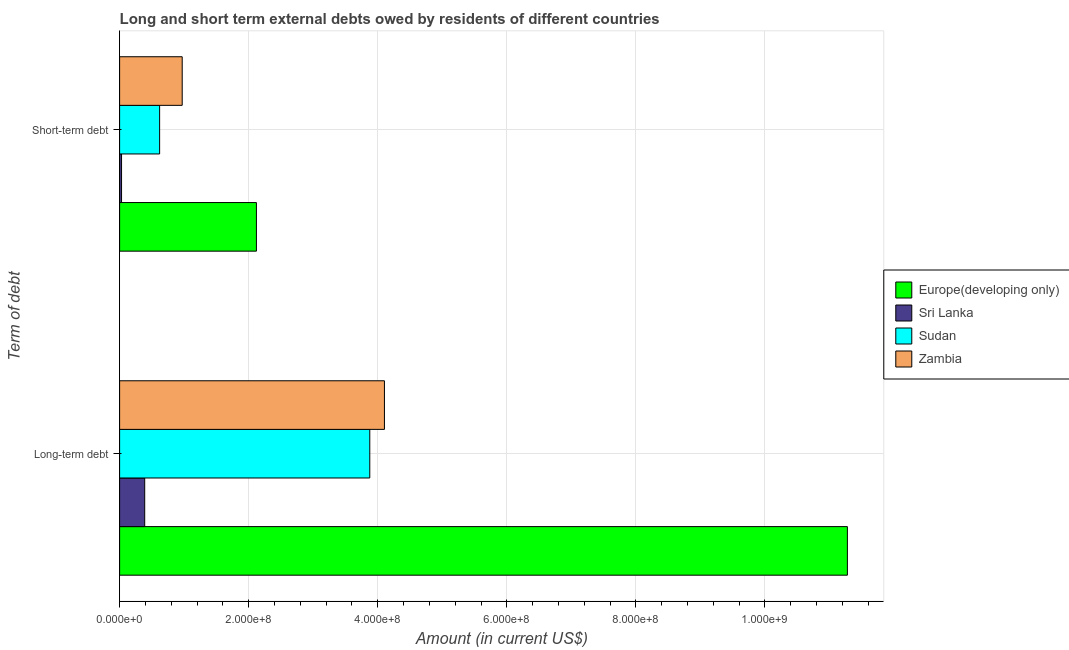Are the number of bars per tick equal to the number of legend labels?
Offer a terse response. Yes. How many bars are there on the 2nd tick from the top?
Make the answer very short. 4. What is the label of the 2nd group of bars from the top?
Provide a succinct answer. Long-term debt. What is the short-term debts owed by residents in Sudan?
Provide a succinct answer. 6.20e+07. Across all countries, what is the maximum long-term debts owed by residents?
Give a very brief answer. 1.13e+09. Across all countries, what is the minimum short-term debts owed by residents?
Provide a short and direct response. 3.00e+06. In which country was the long-term debts owed by residents maximum?
Make the answer very short. Europe(developing only). In which country was the long-term debts owed by residents minimum?
Provide a short and direct response. Sri Lanka. What is the total short-term debts owed by residents in the graph?
Ensure brevity in your answer.  3.74e+08. What is the difference between the long-term debts owed by residents in Europe(developing only) and that in Zambia?
Give a very brief answer. 7.17e+08. What is the difference between the short-term debts owed by residents in Europe(developing only) and the long-term debts owed by residents in Sudan?
Keep it short and to the point. -1.76e+08. What is the average short-term debts owed by residents per country?
Your response must be concise. 9.35e+07. What is the difference between the short-term debts owed by residents and long-term debts owed by residents in Zambia?
Keep it short and to the point. -3.13e+08. In how many countries, is the short-term debts owed by residents greater than 1040000000 US$?
Make the answer very short. 0. What is the ratio of the short-term debts owed by residents in Sudan to that in Europe(developing only)?
Provide a succinct answer. 0.29. Is the short-term debts owed by residents in Sri Lanka less than that in Zambia?
Your answer should be very brief. Yes. What does the 4th bar from the top in Long-term debt represents?
Provide a succinct answer. Europe(developing only). What does the 4th bar from the bottom in Short-term debt represents?
Your answer should be very brief. Zambia. Are all the bars in the graph horizontal?
Keep it short and to the point. Yes. How many countries are there in the graph?
Provide a short and direct response. 4. Does the graph contain any zero values?
Your response must be concise. No. What is the title of the graph?
Your answer should be very brief. Long and short term external debts owed by residents of different countries. What is the label or title of the X-axis?
Provide a succinct answer. Amount (in current US$). What is the label or title of the Y-axis?
Give a very brief answer. Term of debt. What is the Amount (in current US$) of Europe(developing only) in Long-term debt?
Offer a terse response. 1.13e+09. What is the Amount (in current US$) of Sri Lanka in Long-term debt?
Ensure brevity in your answer.  3.89e+07. What is the Amount (in current US$) in Sudan in Long-term debt?
Give a very brief answer. 3.88e+08. What is the Amount (in current US$) in Zambia in Long-term debt?
Keep it short and to the point. 4.10e+08. What is the Amount (in current US$) in Europe(developing only) in Short-term debt?
Offer a terse response. 2.12e+08. What is the Amount (in current US$) of Sri Lanka in Short-term debt?
Offer a terse response. 3.00e+06. What is the Amount (in current US$) in Sudan in Short-term debt?
Your response must be concise. 6.20e+07. What is the Amount (in current US$) of Zambia in Short-term debt?
Ensure brevity in your answer.  9.70e+07. Across all Term of debt, what is the maximum Amount (in current US$) of Europe(developing only)?
Your response must be concise. 1.13e+09. Across all Term of debt, what is the maximum Amount (in current US$) in Sri Lanka?
Ensure brevity in your answer.  3.89e+07. Across all Term of debt, what is the maximum Amount (in current US$) of Sudan?
Your answer should be very brief. 3.88e+08. Across all Term of debt, what is the maximum Amount (in current US$) in Zambia?
Provide a short and direct response. 4.10e+08. Across all Term of debt, what is the minimum Amount (in current US$) of Europe(developing only)?
Keep it short and to the point. 2.12e+08. Across all Term of debt, what is the minimum Amount (in current US$) of Sri Lanka?
Ensure brevity in your answer.  3.00e+06. Across all Term of debt, what is the minimum Amount (in current US$) of Sudan?
Offer a very short reply. 6.20e+07. Across all Term of debt, what is the minimum Amount (in current US$) of Zambia?
Offer a very short reply. 9.70e+07. What is the total Amount (in current US$) in Europe(developing only) in the graph?
Provide a short and direct response. 1.34e+09. What is the total Amount (in current US$) in Sri Lanka in the graph?
Give a very brief answer. 4.19e+07. What is the total Amount (in current US$) of Sudan in the graph?
Your answer should be very brief. 4.50e+08. What is the total Amount (in current US$) of Zambia in the graph?
Provide a succinct answer. 5.07e+08. What is the difference between the Amount (in current US$) in Europe(developing only) in Long-term debt and that in Short-term debt?
Offer a very short reply. 9.16e+08. What is the difference between the Amount (in current US$) in Sri Lanka in Long-term debt and that in Short-term debt?
Ensure brevity in your answer.  3.59e+07. What is the difference between the Amount (in current US$) in Sudan in Long-term debt and that in Short-term debt?
Offer a very short reply. 3.26e+08. What is the difference between the Amount (in current US$) in Zambia in Long-term debt and that in Short-term debt?
Your answer should be very brief. 3.13e+08. What is the difference between the Amount (in current US$) of Europe(developing only) in Long-term debt and the Amount (in current US$) of Sri Lanka in Short-term debt?
Keep it short and to the point. 1.12e+09. What is the difference between the Amount (in current US$) in Europe(developing only) in Long-term debt and the Amount (in current US$) in Sudan in Short-term debt?
Give a very brief answer. 1.07e+09. What is the difference between the Amount (in current US$) of Europe(developing only) in Long-term debt and the Amount (in current US$) of Zambia in Short-term debt?
Ensure brevity in your answer.  1.03e+09. What is the difference between the Amount (in current US$) of Sri Lanka in Long-term debt and the Amount (in current US$) of Sudan in Short-term debt?
Offer a very short reply. -2.31e+07. What is the difference between the Amount (in current US$) in Sri Lanka in Long-term debt and the Amount (in current US$) in Zambia in Short-term debt?
Provide a short and direct response. -5.81e+07. What is the difference between the Amount (in current US$) of Sudan in Long-term debt and the Amount (in current US$) of Zambia in Short-term debt?
Your answer should be very brief. 2.91e+08. What is the average Amount (in current US$) of Europe(developing only) per Term of debt?
Ensure brevity in your answer.  6.70e+08. What is the average Amount (in current US$) of Sri Lanka per Term of debt?
Ensure brevity in your answer.  2.09e+07. What is the average Amount (in current US$) of Sudan per Term of debt?
Offer a terse response. 2.25e+08. What is the average Amount (in current US$) in Zambia per Term of debt?
Give a very brief answer. 2.54e+08. What is the difference between the Amount (in current US$) of Europe(developing only) and Amount (in current US$) of Sri Lanka in Long-term debt?
Make the answer very short. 1.09e+09. What is the difference between the Amount (in current US$) of Europe(developing only) and Amount (in current US$) of Sudan in Long-term debt?
Ensure brevity in your answer.  7.40e+08. What is the difference between the Amount (in current US$) of Europe(developing only) and Amount (in current US$) of Zambia in Long-term debt?
Your answer should be compact. 7.17e+08. What is the difference between the Amount (in current US$) of Sri Lanka and Amount (in current US$) of Sudan in Long-term debt?
Keep it short and to the point. -3.49e+08. What is the difference between the Amount (in current US$) in Sri Lanka and Amount (in current US$) in Zambia in Long-term debt?
Your answer should be compact. -3.71e+08. What is the difference between the Amount (in current US$) in Sudan and Amount (in current US$) in Zambia in Long-term debt?
Offer a very short reply. -2.27e+07. What is the difference between the Amount (in current US$) in Europe(developing only) and Amount (in current US$) in Sri Lanka in Short-term debt?
Your answer should be compact. 2.09e+08. What is the difference between the Amount (in current US$) of Europe(developing only) and Amount (in current US$) of Sudan in Short-term debt?
Your answer should be compact. 1.50e+08. What is the difference between the Amount (in current US$) of Europe(developing only) and Amount (in current US$) of Zambia in Short-term debt?
Your response must be concise. 1.15e+08. What is the difference between the Amount (in current US$) of Sri Lanka and Amount (in current US$) of Sudan in Short-term debt?
Your answer should be compact. -5.90e+07. What is the difference between the Amount (in current US$) in Sri Lanka and Amount (in current US$) in Zambia in Short-term debt?
Your answer should be compact. -9.40e+07. What is the difference between the Amount (in current US$) of Sudan and Amount (in current US$) of Zambia in Short-term debt?
Offer a terse response. -3.50e+07. What is the ratio of the Amount (in current US$) of Europe(developing only) in Long-term debt to that in Short-term debt?
Your answer should be very brief. 5.32. What is the ratio of the Amount (in current US$) in Sri Lanka in Long-term debt to that in Short-term debt?
Your answer should be compact. 12.96. What is the ratio of the Amount (in current US$) in Sudan in Long-term debt to that in Short-term debt?
Your response must be concise. 6.25. What is the ratio of the Amount (in current US$) in Zambia in Long-term debt to that in Short-term debt?
Provide a succinct answer. 4.23. What is the difference between the highest and the second highest Amount (in current US$) of Europe(developing only)?
Make the answer very short. 9.16e+08. What is the difference between the highest and the second highest Amount (in current US$) in Sri Lanka?
Ensure brevity in your answer.  3.59e+07. What is the difference between the highest and the second highest Amount (in current US$) of Sudan?
Ensure brevity in your answer.  3.26e+08. What is the difference between the highest and the second highest Amount (in current US$) in Zambia?
Your answer should be compact. 3.13e+08. What is the difference between the highest and the lowest Amount (in current US$) in Europe(developing only)?
Give a very brief answer. 9.16e+08. What is the difference between the highest and the lowest Amount (in current US$) of Sri Lanka?
Provide a short and direct response. 3.59e+07. What is the difference between the highest and the lowest Amount (in current US$) in Sudan?
Your answer should be very brief. 3.26e+08. What is the difference between the highest and the lowest Amount (in current US$) in Zambia?
Your answer should be compact. 3.13e+08. 